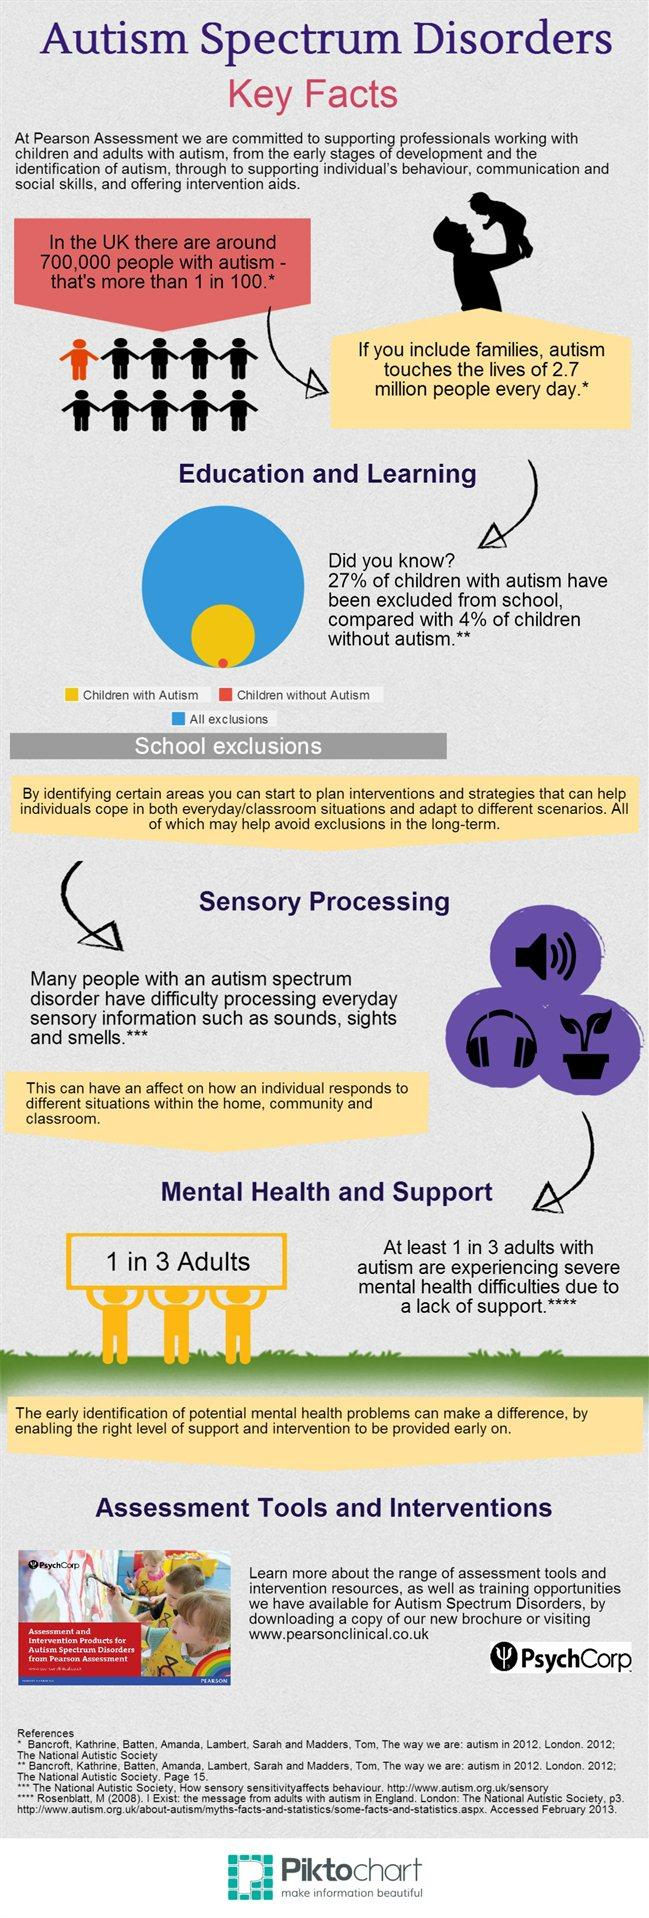Identify some key points in this picture. According to data, autistic students make up 27% of school exclusions. According to recent estimates, approximately 1% of the population in the United Kingdom has autism. It is commonly believed that autistic individuals are unable to process certain sensory inputs, such as sounds, sights, and smells, to the same extent as non-autistic individuals. In the pie chart, yellow is used to represent children with autism. According to research, one in three adults with autism also suffers from acute mental health problems. 